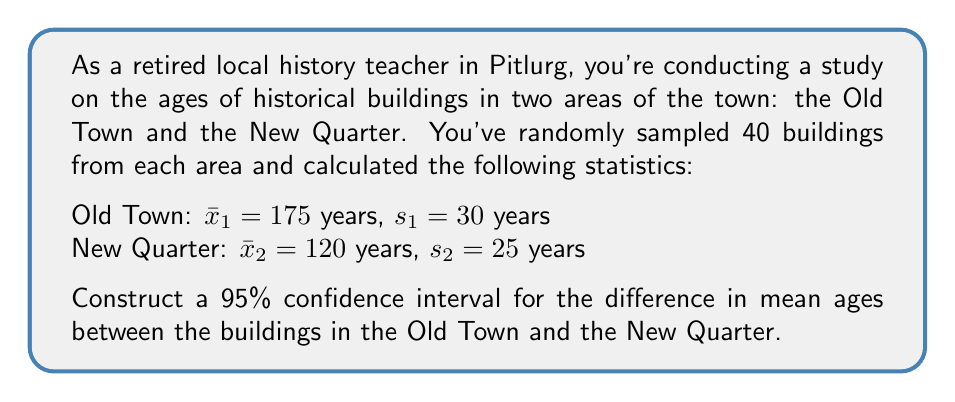Show me your answer to this math problem. Let's approach this step-by-step:

1) The formula for the confidence interval for the difference between two means is:

   $$(\bar{x}_1 - \bar{x}_2) \pm t_{\alpha/2} \sqrt{\frac{s_1^2}{n_1} + \frac{s_2^2}{n_2}}$$

   where $t_{\alpha/2}$ is the t-value for a 95% confidence interval with degrees of freedom:

   $$df = \frac{(\frac{s_1^2}{n_1} + \frac{s_2^2}{n_2})^2}{\frac{(s_1^2/n_1)^2}{n_1-1} + \frac{(s_2^2/n_2)^2}{n_2-1}}$$

2) Let's calculate the difference in means:
   $\bar{x}_1 - \bar{x}_2 = 175 - 120 = 55$ years

3) Now, let's calculate the degrees of freedom:
   $$df = \frac{(\frac{30^2}{40} + \frac{25^2}{40})^2}{\frac{(30^2/40)^2}{39} + \frac{(25^2/40)^2}{39}} \approx 76.8$$

   Rounding down to be conservative, we use $df = 76$.

4) For a 95% confidence interval with 76 degrees of freedom, $t_{\alpha/2} \approx 1.992$

5) Now let's calculate the standard error:
   $$SE = \sqrt{\frac{s_1^2}{n_1} + \frac{s_2^2}{n_2}} = \sqrt{\frac{30^2}{40} + \frac{25^2}{40}} \approx 6.16$$

6) The margin of error is:
   $1.992 * 6.16 \approx 12.27$

7) Therefore, the confidence interval is:
   $55 \pm 12.27$, or $(42.73, 67.27)$
Answer: (42.73, 67.27) years 